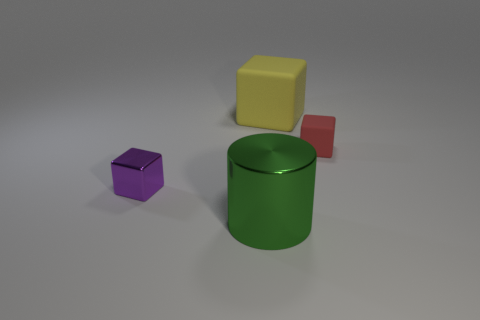How many cubes are both to the left of the yellow cube and behind the small red block?
Make the answer very short. 0. There is a thing that is behind the red thing; what material is it?
Provide a succinct answer. Rubber. What is the size of the green cylinder that is made of the same material as the purple object?
Ensure brevity in your answer.  Large. Are there any big rubber things behind the green object?
Your answer should be compact. Yes. There is a purple object that is the same shape as the big yellow object; what size is it?
Keep it short and to the point. Small. Does the large metal thing have the same color as the matte thing in front of the yellow object?
Your answer should be compact. No. Is the color of the tiny shiny thing the same as the big cylinder?
Provide a short and direct response. No. Are there fewer green objects than rubber objects?
Keep it short and to the point. Yes. What number of other objects are the same color as the small shiny thing?
Give a very brief answer. 0. How many yellow matte things are there?
Provide a succinct answer. 1. 